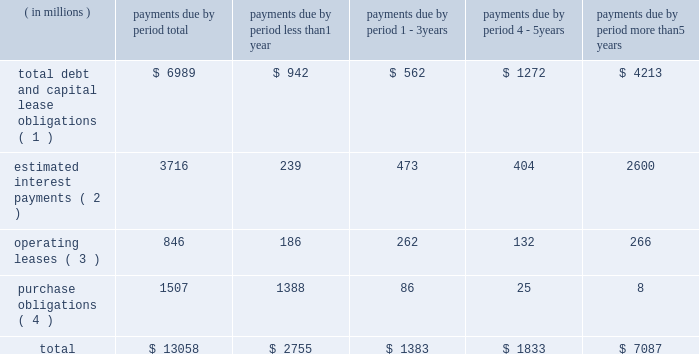Bhge 2018 form 10-k | 41 estimate would equal up to 5% ( 5 % ) of annual revenue .
The expenditures are expected to be used primarily for normal , recurring items necessary to support our business .
We also anticipate making income tax payments in the range of $ 425 million to $ 475 million in 2019 .
Contractual obligations in the table below , we set forth our contractual obligations as of december 31 , 2018 .
Certain amounts included in this table are based on our estimates and assumptions about these obligations , including their duration , anticipated actions by third parties and other factors .
The contractual obligations we will actually pay in future periods may vary from those reflected in the table because the estimates and assumptions are subjective. .
( 1 ) amounts represent the expected cash payments for the principal amounts related to our debt , including capital lease obligations .
Amounts for debt do not include any deferred issuance costs or unamortized discounts or premiums including step up in the value of the debt on the acquisition of baker hughes .
Expected cash payments for interest are excluded from these amounts .
Total debt and capital lease obligations includes $ 896 million payable to ge and its affiliates .
As there is no fixed payment schedule on the amount payable to ge and its affiliates we have classified it as payable in less than one year .
( 2 ) amounts represent the expected cash payments for interest on our long-term debt and capital lease obligations .
( 3 ) amounts represent the future minimum payments under noncancelable operating leases with initial or remaining terms of one year or more .
We enter into operating leases , some of which include renewal options , however , we have excluded renewal options from the table above unless it is anticipated that we will exercise such renewals .
( 4 ) purchase obligations include expenditures for capital assets for 2019 as well as agreements to purchase goods or services that are enforceable and legally binding and that specify all significant terms , including : fixed or minimum quantities to be purchased ; fixed , minimum or variable price provisions ; and the approximate timing of the transaction .
Due to the uncertainty with respect to the timing of potential future cash outflows associated with our uncertain tax positions , we are unable to make reasonable estimates of the period of cash settlement , if any , to the respective taxing authorities .
Therefore , $ 597 million in uncertain tax positions , including interest and penalties , have been excluded from the contractual obligations table above .
See "note 12 .
Income taxes" of the notes to consolidated and combined financial statements in item 8 herein for further information .
We have certain defined benefit pension and other post-retirement benefit plans covering certain of our u.s .
And international employees .
During 2018 , we made contributions and paid direct benefits of approximately $ 72 million in connection with those plans , and we anticipate funding approximately $ 41 million during 2019 .
Amounts for pension funding obligations are based on assumptions that are subject to change , therefore , we are currently not able to reasonably estimate our contribution figures after 2019 .
See "note 11 .
Employee benefit plans" of the notes to consolidated and combined financial statements in item 8 herein for further information .
Off-balance sheet arrangements in the normal course of business with customers , vendors and others , we have entered into off-balance sheet arrangements , such as surety bonds for performance , letters of credit and other bank issued guarantees , which totaled approximately $ 3.6 billion at december 31 , 2018 .
It is not practicable to estimate the fair value of these financial instruments .
None of the off-balance sheet arrangements either has , or is likely to have , a material effect on our consolidated and combined financial statements. .
What portion of total contractual obligations is expected to be paid as interest payments? 
Computations: (3716 / 13058)
Answer: 0.28458. 